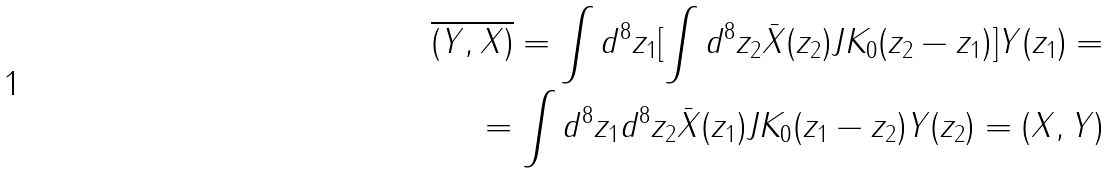<formula> <loc_0><loc_0><loc_500><loc_500>\overline { ( Y , X ) } = \int d ^ { 8 } z _ { 1 } [ \int d ^ { 8 } z _ { 2 } \bar { X } ( z _ { 2 } ) J K _ { 0 } ( z _ { 2 } - z _ { 1 } ) ] Y ( z _ { 1 } ) = \\ = \int d ^ { 8 } z _ { 1 } d ^ { 8 } z _ { 2 } \bar { X } ( z _ { 1 } ) J K _ { 0 } ( z _ { 1 } - z _ { 2 } ) Y ( z _ { 2 } ) = ( X , Y )</formula> 